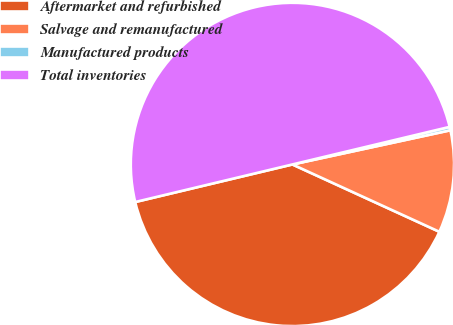Convert chart. <chart><loc_0><loc_0><loc_500><loc_500><pie_chart><fcel>Aftermarket and refurbished<fcel>Salvage and remanufactured<fcel>Manufactured products<fcel>Total inventories<nl><fcel>39.43%<fcel>10.23%<fcel>0.34%<fcel>50.0%<nl></chart> 